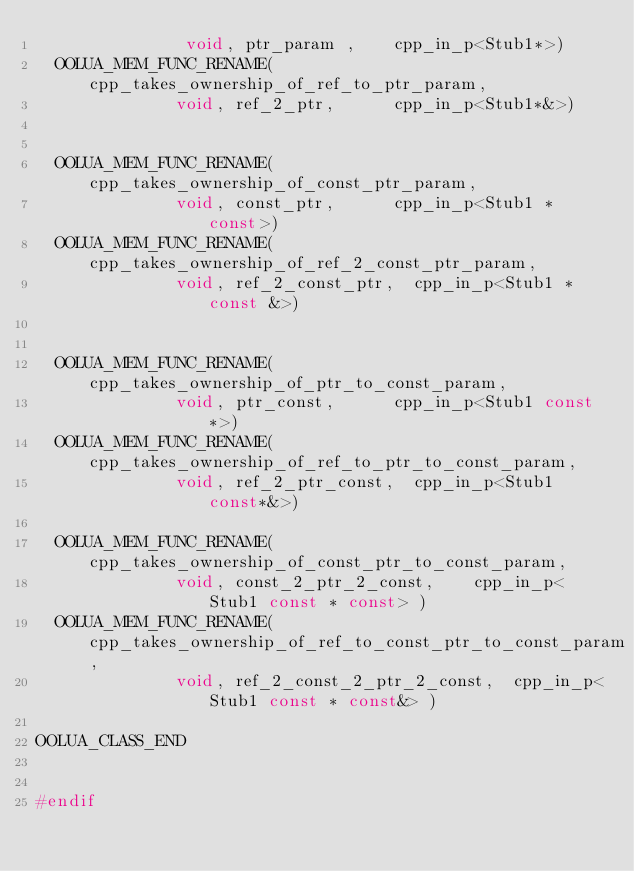<code> <loc_0><loc_0><loc_500><loc_500><_C_>						   void, ptr_param ,		cpp_in_p<Stub1*>)
	OOLUA_MEM_FUNC_RENAME(cpp_takes_ownership_of_ref_to_ptr_param,
						  void, ref_2_ptr,			cpp_in_p<Stub1*&>)


	OOLUA_MEM_FUNC_RENAME(cpp_takes_ownership_of_const_ptr_param,
						  void, const_ptr,			cpp_in_p<Stub1 * const>)
	OOLUA_MEM_FUNC_RENAME(cpp_takes_ownership_of_ref_2_const_ptr_param,
						  void, ref_2_const_ptr,	cpp_in_p<Stub1 * const &>)


	OOLUA_MEM_FUNC_RENAME(cpp_takes_ownership_of_ptr_to_const_param,
						  void, ptr_const,			cpp_in_p<Stub1 const*>)
	OOLUA_MEM_FUNC_RENAME(cpp_takes_ownership_of_ref_to_ptr_to_const_param,
						  void, ref_2_ptr_const,	cpp_in_p<Stub1 const*&>)

	OOLUA_MEM_FUNC_RENAME(cpp_takes_ownership_of_const_ptr_to_const_param,
						  void, const_2_ptr_2_const,		cpp_in_p<Stub1 const * const> )
	OOLUA_MEM_FUNC_RENAME(cpp_takes_ownership_of_ref_to_const_ptr_to_const_param,
						  void, ref_2_const_2_ptr_2_const,	cpp_in_p<Stub1 const * const&> )

OOLUA_CLASS_END


#endif

</code> 